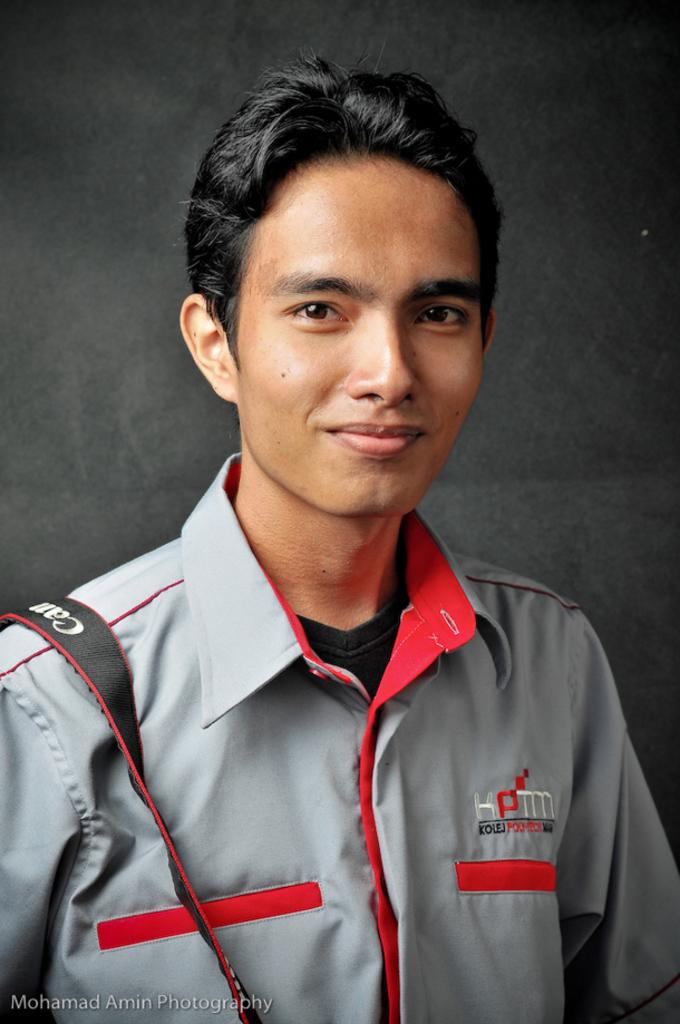What are the letters on this mans shirt?
Your response must be concise. Kptm. What is written on the man's strap?
Provide a short and direct response. Canon. 